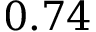<formula> <loc_0><loc_0><loc_500><loc_500>0 . 7 4</formula> 